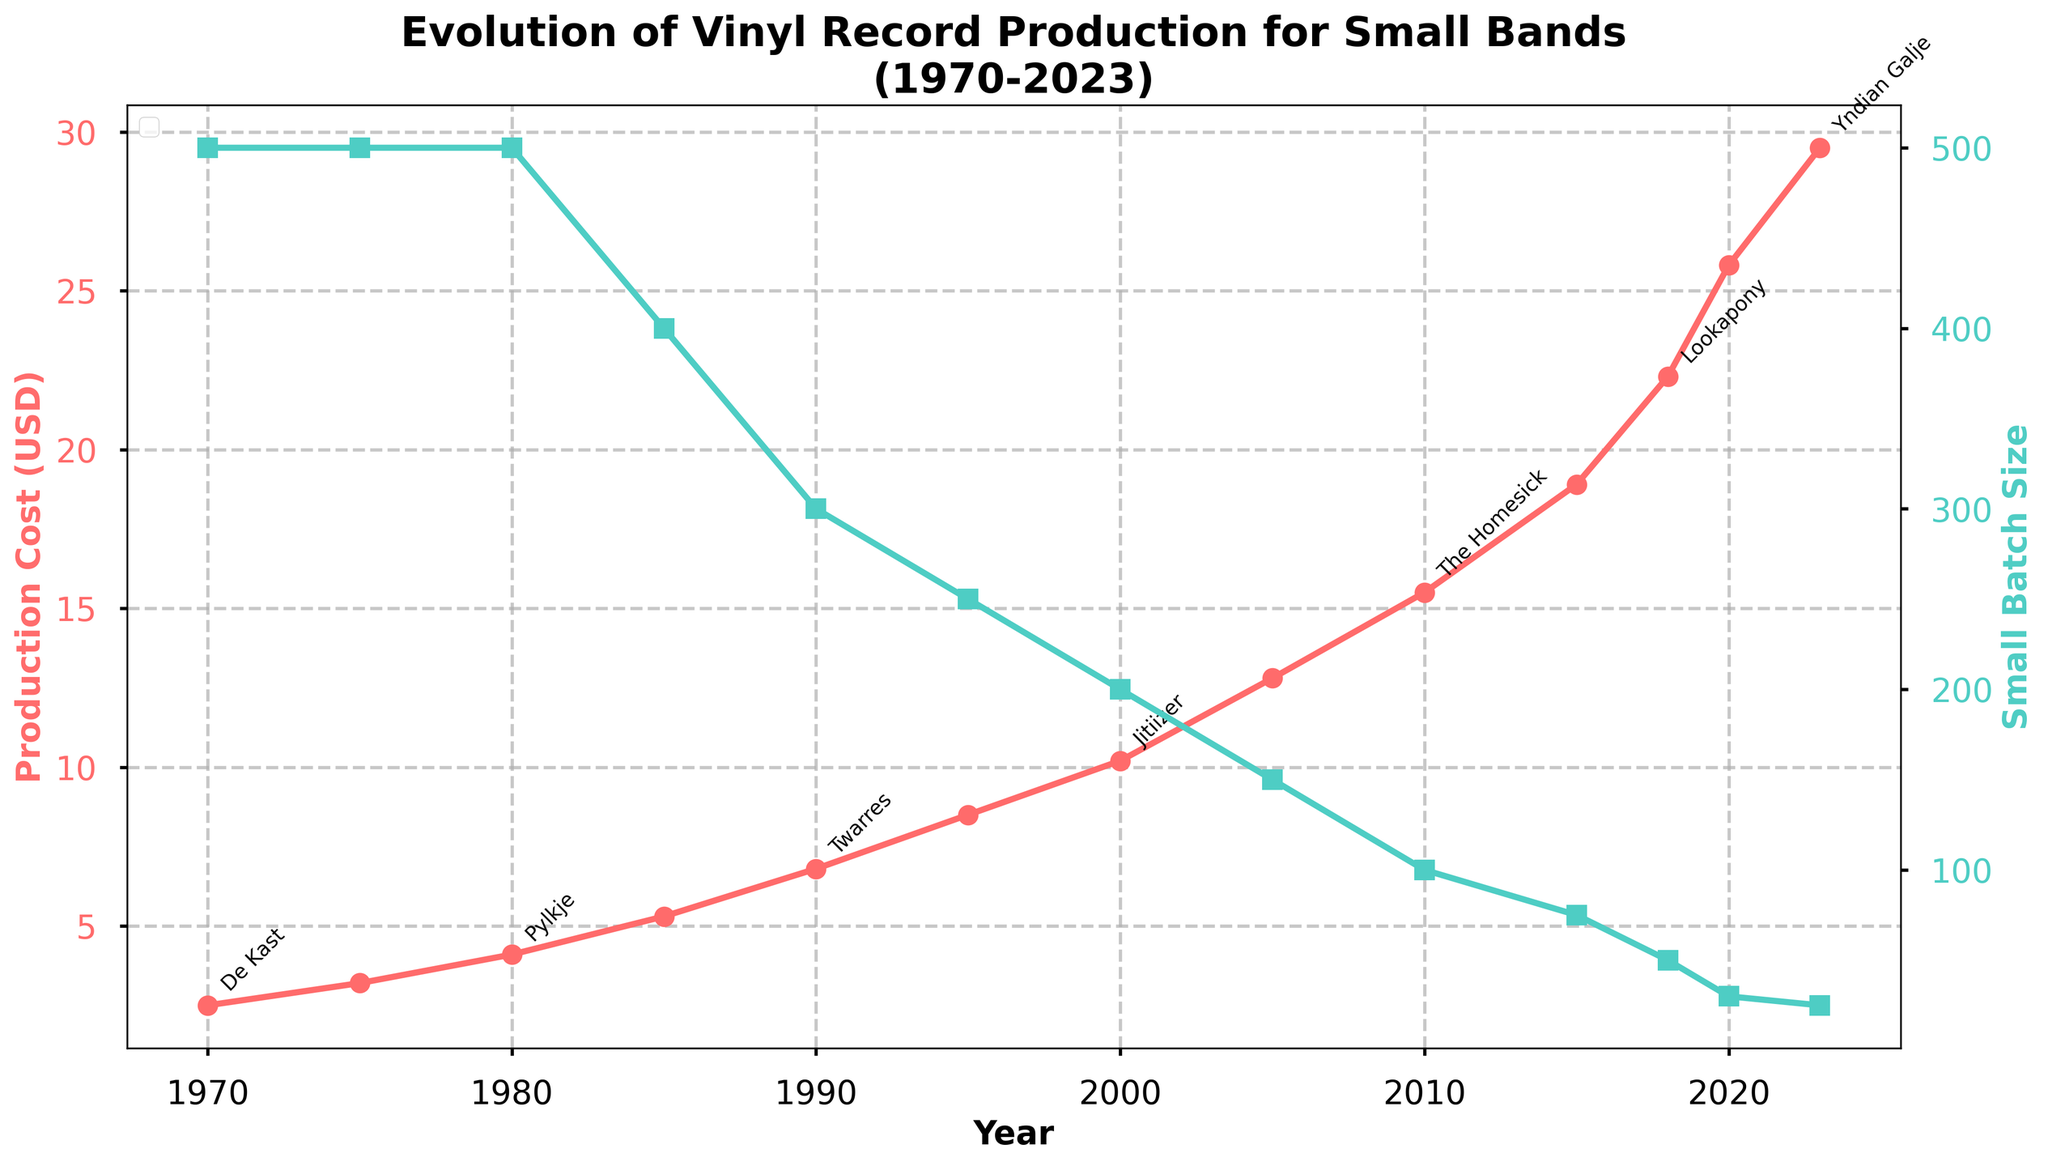When did the production cost for small-batch vinyl records surpass $10? First, identify the point where the production cost crosses $10 on the production cost line (the red line). This is around the year 2000.
Answer: 2000 What was the production cost when the small batch size was 50 units? Locate the point on the small batch size line (the green line) where the batch size drops to 50 units, which happens in 2018. Then, check the corresponding production cost at that year.
Answer: $22.30 How has the production cost trended from 1970 to 2023? Observe the overall trajectory of the red line from 1970 to 2023. Notice that the production cost has increased steadily over time.
Answer: Increased What is the difference in production cost between 1985 and 2023? Find the production costs for 1985 ($5.30) and 2023 ($29.50). Subtract the 1985 cost from the 2023 cost: $29.50 - $5.30 = $24.20.
Answer: $24.20 Which year had the highest small batch size and what was the production cost then? Identify the highest small batch size on the green line, which is 500 units. This occurred in 1970. The production cost at that time was $2.50.
Answer: 1970, $2.50 What notable Frisian band was associated with the lowest production cost? Check the annotations next to the data points to find the lowest point on the red line, which is in 1970 with a cost of $2.50. The notable Frisian band at that point is De Kast.
Answer: De Kast In which year was the small batch size equal to 100 units? Look at the point on the small batch size line where it equals 100 units, which occurs around 2010.
Answer: 2010 What is the average production cost from 1970 to 1980? Sum the production costs for 1970 ($2.50), 1975 ($3.20), and 1980 ($4.10) and divide by the number of years (3): (2.50 + 3.20 + 4.10) / 3 = $3.27.
Answer: $3.27 How much did the production cost increase between 2005 and 2020? Find the production costs for 2005 ($12.80) and 2020 ($25.80). Subtract the 2005 cost from the 2020 cost: $25.80 - $12.80 = $13.00.
Answer: $13.00 